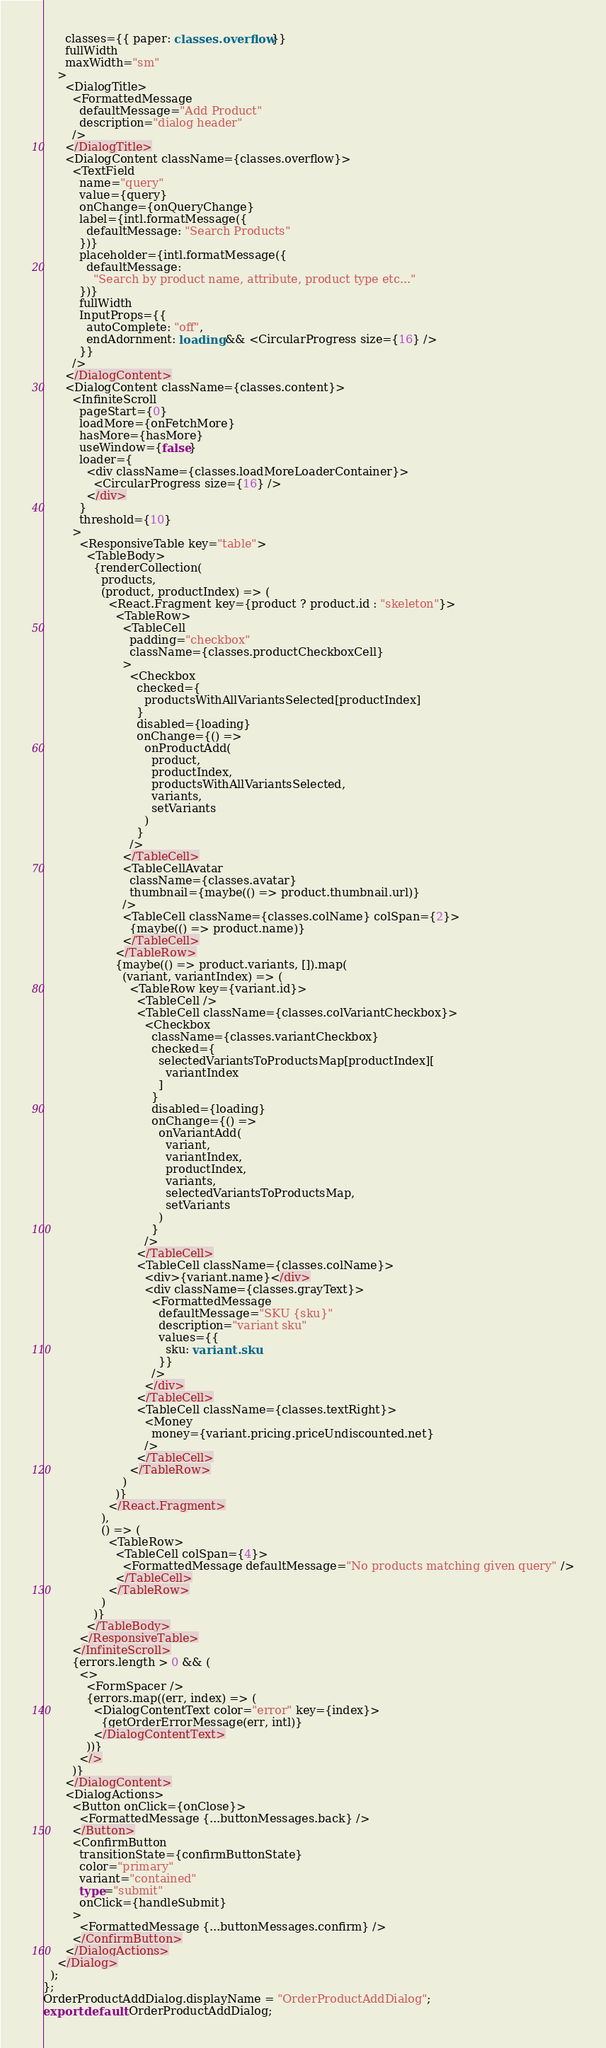<code> <loc_0><loc_0><loc_500><loc_500><_TypeScript_>      classes={{ paper: classes.overflow }}
      fullWidth
      maxWidth="sm"
    >
      <DialogTitle>
        <FormattedMessage
          defaultMessage="Add Product"
          description="dialog header"
        />
      </DialogTitle>
      <DialogContent className={classes.overflow}>
        <TextField
          name="query"
          value={query}
          onChange={onQueryChange}
          label={intl.formatMessage({
            defaultMessage: "Search Products"
          })}
          placeholder={intl.formatMessage({
            defaultMessage:
              "Search by product name, attribute, product type etc..."
          })}
          fullWidth
          InputProps={{
            autoComplete: "off",
            endAdornment: loading && <CircularProgress size={16} />
          }}
        />
      </DialogContent>
      <DialogContent className={classes.content}>
        <InfiniteScroll
          pageStart={0}
          loadMore={onFetchMore}
          hasMore={hasMore}
          useWindow={false}
          loader={
            <div className={classes.loadMoreLoaderContainer}>
              <CircularProgress size={16} />
            </div>
          }
          threshold={10}
        >
          <ResponsiveTable key="table">
            <TableBody>
              {renderCollection(
                products,
                (product, productIndex) => (
                  <React.Fragment key={product ? product.id : "skeleton"}>
                    <TableRow>
                      <TableCell
                        padding="checkbox"
                        className={classes.productCheckboxCell}
                      >
                        <Checkbox
                          checked={
                            productsWithAllVariantsSelected[productIndex]
                          }
                          disabled={loading}
                          onChange={() =>
                            onProductAdd(
                              product,
                              productIndex,
                              productsWithAllVariantsSelected,
                              variants,
                              setVariants
                            )
                          }
                        />
                      </TableCell>
                      <TableCellAvatar
                        className={classes.avatar}
                        thumbnail={maybe(() => product.thumbnail.url)}
                      />
                      <TableCell className={classes.colName} colSpan={2}>
                        {maybe(() => product.name)}
                      </TableCell>
                    </TableRow>
                    {maybe(() => product.variants, []).map(
                      (variant, variantIndex) => (
                        <TableRow key={variant.id}>
                          <TableCell />
                          <TableCell className={classes.colVariantCheckbox}>
                            <Checkbox
                              className={classes.variantCheckbox}
                              checked={
                                selectedVariantsToProductsMap[productIndex][
                                  variantIndex
                                ]
                              }
                              disabled={loading}
                              onChange={() =>
                                onVariantAdd(
                                  variant,
                                  variantIndex,
                                  productIndex,
                                  variants,
                                  selectedVariantsToProductsMap,
                                  setVariants
                                )
                              }
                            />
                          </TableCell>
                          <TableCell className={classes.colName}>
                            <div>{variant.name}</div>
                            <div className={classes.grayText}>
                              <FormattedMessage
                                defaultMessage="SKU {sku}"
                                description="variant sku"
                                values={{
                                  sku: variant.sku
                                }}
                              />
                            </div>
                          </TableCell>
                          <TableCell className={classes.textRight}>
                            <Money
                              money={variant.pricing.priceUndiscounted.net}
                            />
                          </TableCell>
                        </TableRow>
                      )
                    )}
                  </React.Fragment>
                ),
                () => (
                  <TableRow>
                    <TableCell colSpan={4}>
                      <FormattedMessage defaultMessage="No products matching given query" />
                    </TableCell>
                  </TableRow>
                )
              )}
            </TableBody>
          </ResponsiveTable>
        </InfiniteScroll>
        {errors.length > 0 && (
          <>
            <FormSpacer />
            {errors.map((err, index) => (
              <DialogContentText color="error" key={index}>
                {getOrderErrorMessage(err, intl)}
              </DialogContentText>
            ))}
          </>
        )}
      </DialogContent>
      <DialogActions>
        <Button onClick={onClose}>
          <FormattedMessage {...buttonMessages.back} />
        </Button>
        <ConfirmButton
          transitionState={confirmButtonState}
          color="primary"
          variant="contained"
          type="submit"
          onClick={handleSubmit}
        >
          <FormattedMessage {...buttonMessages.confirm} />
        </ConfirmButton>
      </DialogActions>
    </Dialog>
  );
};
OrderProductAddDialog.displayName = "OrderProductAddDialog";
export default OrderProductAddDialog;
</code> 